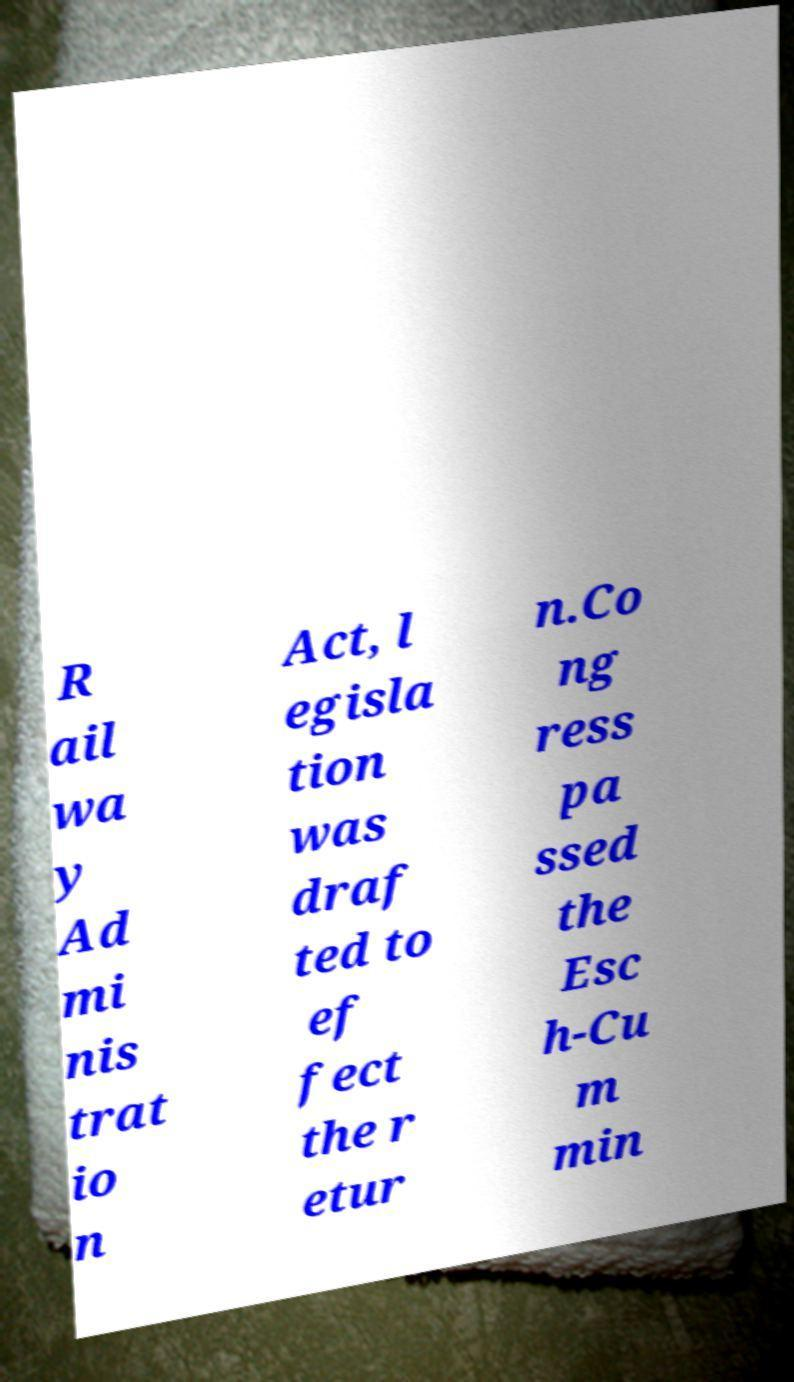I need the written content from this picture converted into text. Can you do that? R ail wa y Ad mi nis trat io n Act, l egisla tion was draf ted to ef fect the r etur n.Co ng ress pa ssed the Esc h-Cu m min 